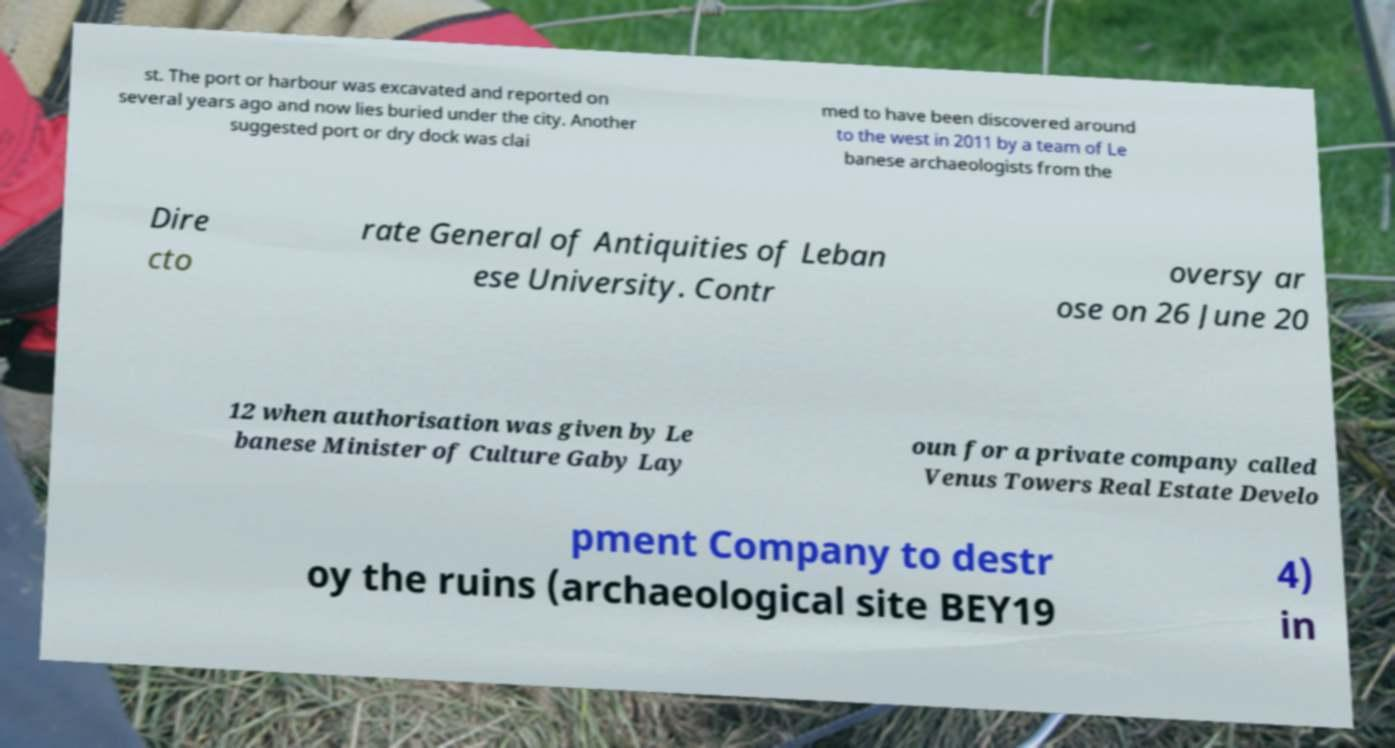Could you assist in decoding the text presented in this image and type it out clearly? st. The port or harbour was excavated and reported on several years ago and now lies buried under the city. Another suggested port or dry dock was clai med to have been discovered around to the west in 2011 by a team of Le banese archaeologists from the Dire cto rate General of Antiquities of Leban ese University. Contr oversy ar ose on 26 June 20 12 when authorisation was given by Le banese Minister of Culture Gaby Lay oun for a private company called Venus Towers Real Estate Develo pment Company to destr oy the ruins (archaeological site BEY19 4) in 